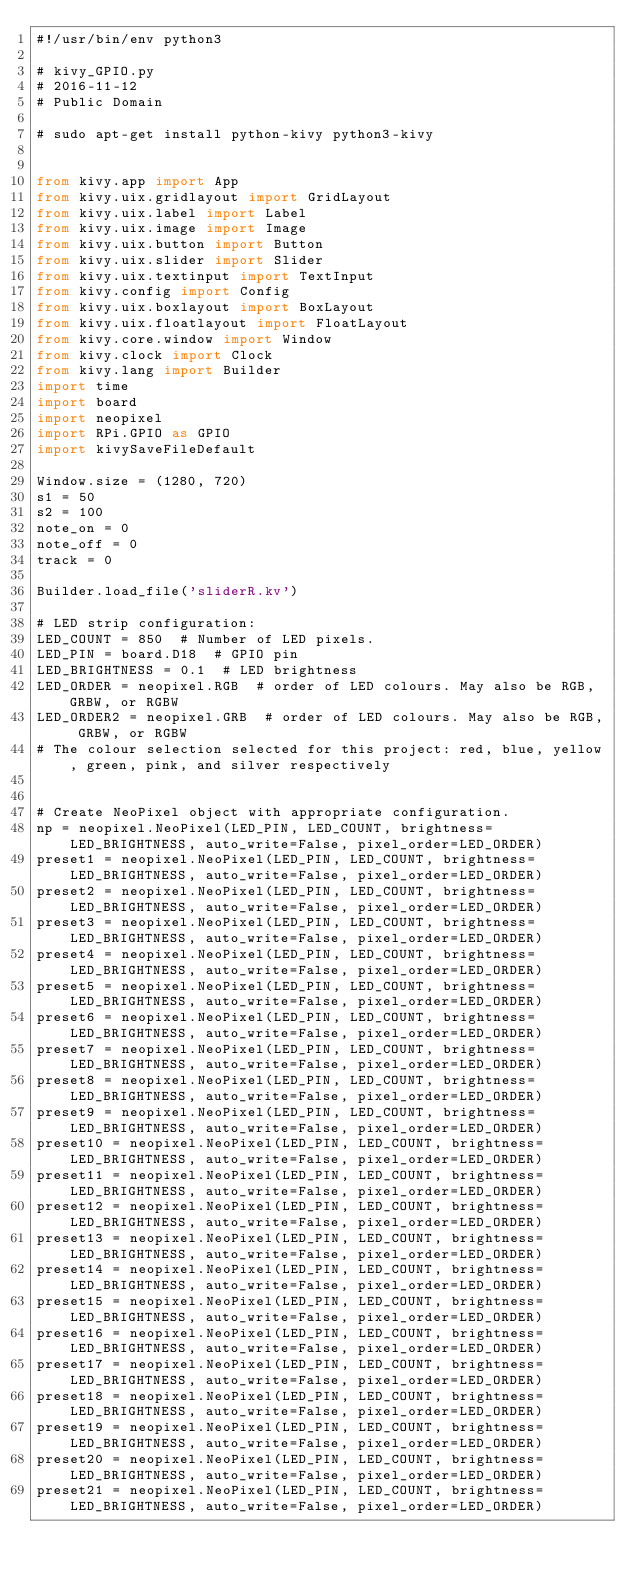Convert code to text. <code><loc_0><loc_0><loc_500><loc_500><_Python_>#!/usr/bin/env python3

# kivy_GPIO.py
# 2016-11-12
# Public Domain

# sudo apt-get install python-kivy python3-kivy


from kivy.app import App
from kivy.uix.gridlayout import GridLayout
from kivy.uix.label import Label
from kivy.uix.image import Image
from kivy.uix.button import Button
from kivy.uix.slider import Slider
from kivy.uix.textinput import TextInput
from kivy.config import Config
from kivy.uix.boxlayout import BoxLayout
from kivy.uix.floatlayout import FloatLayout
from kivy.core.window import Window
from kivy.clock import Clock
from kivy.lang import Builder
import time
import board
import neopixel
import RPi.GPIO as GPIO
import kivySaveFileDefault

Window.size = (1280, 720)
s1 = 50
s2 = 100
note_on = 0
note_off = 0
track = 0

Builder.load_file('sliderR.kv')

# LED strip configuration:
LED_COUNT = 850  # Number of LED pixels.
LED_PIN = board.D18  # GPIO pin
LED_BRIGHTNESS = 0.1  # LED brightness
LED_ORDER = neopixel.RGB  # order of LED colours. May also be RGB, GRBW, or RGBW
LED_ORDER2 = neopixel.GRB  # order of LED colours. May also be RGB, GRBW, or RGBW
# The colour selection selected for this project: red, blue, yellow, green, pink, and silver respectively


# Create NeoPixel object with appropriate configuration.
np = neopixel.NeoPixel(LED_PIN, LED_COUNT, brightness=LED_BRIGHTNESS, auto_write=False, pixel_order=LED_ORDER)
preset1 = neopixel.NeoPixel(LED_PIN, LED_COUNT, brightness=LED_BRIGHTNESS, auto_write=False, pixel_order=LED_ORDER)
preset2 = neopixel.NeoPixel(LED_PIN, LED_COUNT, brightness=LED_BRIGHTNESS, auto_write=False, pixel_order=LED_ORDER)
preset3 = neopixel.NeoPixel(LED_PIN, LED_COUNT, brightness=LED_BRIGHTNESS, auto_write=False, pixel_order=LED_ORDER)
preset4 = neopixel.NeoPixel(LED_PIN, LED_COUNT, brightness=LED_BRIGHTNESS, auto_write=False, pixel_order=LED_ORDER)
preset5 = neopixel.NeoPixel(LED_PIN, LED_COUNT, brightness=LED_BRIGHTNESS, auto_write=False, pixel_order=LED_ORDER)
preset6 = neopixel.NeoPixel(LED_PIN, LED_COUNT, brightness=LED_BRIGHTNESS, auto_write=False, pixel_order=LED_ORDER)
preset7 = neopixel.NeoPixel(LED_PIN, LED_COUNT, brightness=LED_BRIGHTNESS, auto_write=False, pixel_order=LED_ORDER)
preset8 = neopixel.NeoPixel(LED_PIN, LED_COUNT, brightness=LED_BRIGHTNESS, auto_write=False, pixel_order=LED_ORDER)
preset9 = neopixel.NeoPixel(LED_PIN, LED_COUNT, brightness=LED_BRIGHTNESS, auto_write=False, pixel_order=LED_ORDER)
preset10 = neopixel.NeoPixel(LED_PIN, LED_COUNT, brightness=LED_BRIGHTNESS, auto_write=False, pixel_order=LED_ORDER)
preset11 = neopixel.NeoPixel(LED_PIN, LED_COUNT, brightness=LED_BRIGHTNESS, auto_write=False, pixel_order=LED_ORDER)
preset12 = neopixel.NeoPixel(LED_PIN, LED_COUNT, brightness=LED_BRIGHTNESS, auto_write=False, pixel_order=LED_ORDER)
preset13 = neopixel.NeoPixel(LED_PIN, LED_COUNT, brightness=LED_BRIGHTNESS, auto_write=False, pixel_order=LED_ORDER)
preset14 = neopixel.NeoPixel(LED_PIN, LED_COUNT, brightness=LED_BRIGHTNESS, auto_write=False, pixel_order=LED_ORDER)
preset15 = neopixel.NeoPixel(LED_PIN, LED_COUNT, brightness=LED_BRIGHTNESS, auto_write=False, pixel_order=LED_ORDER)
preset16 = neopixel.NeoPixel(LED_PIN, LED_COUNT, brightness=LED_BRIGHTNESS, auto_write=False, pixel_order=LED_ORDER)
preset17 = neopixel.NeoPixel(LED_PIN, LED_COUNT, brightness=LED_BRIGHTNESS, auto_write=False, pixel_order=LED_ORDER)
preset18 = neopixel.NeoPixel(LED_PIN, LED_COUNT, brightness=LED_BRIGHTNESS, auto_write=False, pixel_order=LED_ORDER)
preset19 = neopixel.NeoPixel(LED_PIN, LED_COUNT, brightness=LED_BRIGHTNESS, auto_write=False, pixel_order=LED_ORDER)
preset20 = neopixel.NeoPixel(LED_PIN, LED_COUNT, brightness=LED_BRIGHTNESS, auto_write=False, pixel_order=LED_ORDER)
preset21 = neopixel.NeoPixel(LED_PIN, LED_COUNT, brightness=LED_BRIGHTNESS, auto_write=False, pixel_order=LED_ORDER)</code> 